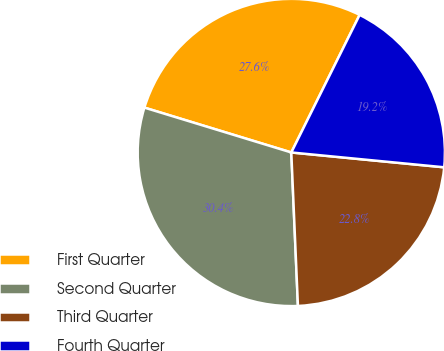Convert chart. <chart><loc_0><loc_0><loc_500><loc_500><pie_chart><fcel>First Quarter<fcel>Second Quarter<fcel>Third Quarter<fcel>Fourth Quarter<nl><fcel>27.62%<fcel>30.4%<fcel>22.77%<fcel>19.2%<nl></chart> 